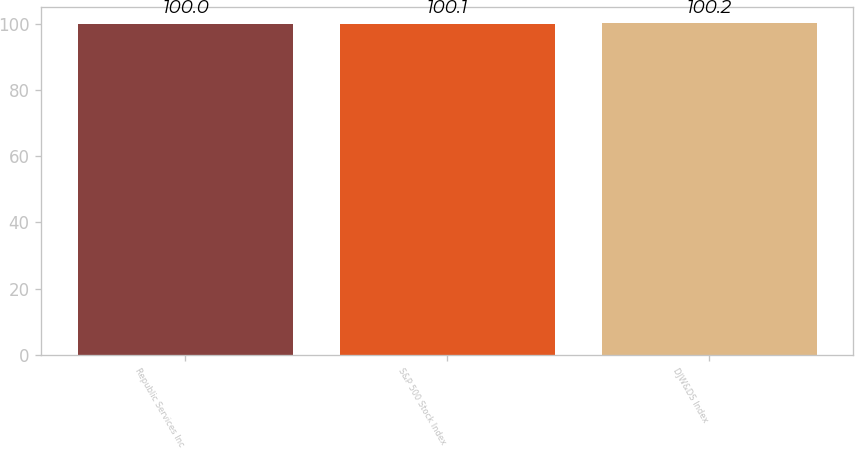<chart> <loc_0><loc_0><loc_500><loc_500><bar_chart><fcel>Republic Services Inc<fcel>S&P 500 Stock Index<fcel>DJW&DS Index<nl><fcel>100<fcel>100.1<fcel>100.2<nl></chart> 